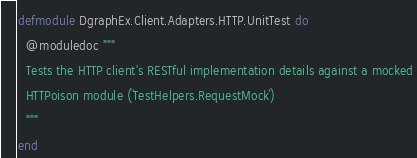Convert code to text. <code><loc_0><loc_0><loc_500><loc_500><_Elixir_>defmodule DgraphEx.Client.Adapters.HTTP.UnitTest do
  @moduledoc """
  Tests the HTTP client's RESTful implementation details against a mocked
  HTTPoison module (`TestHelpers.RequestMock`)
  """
end
</code> 